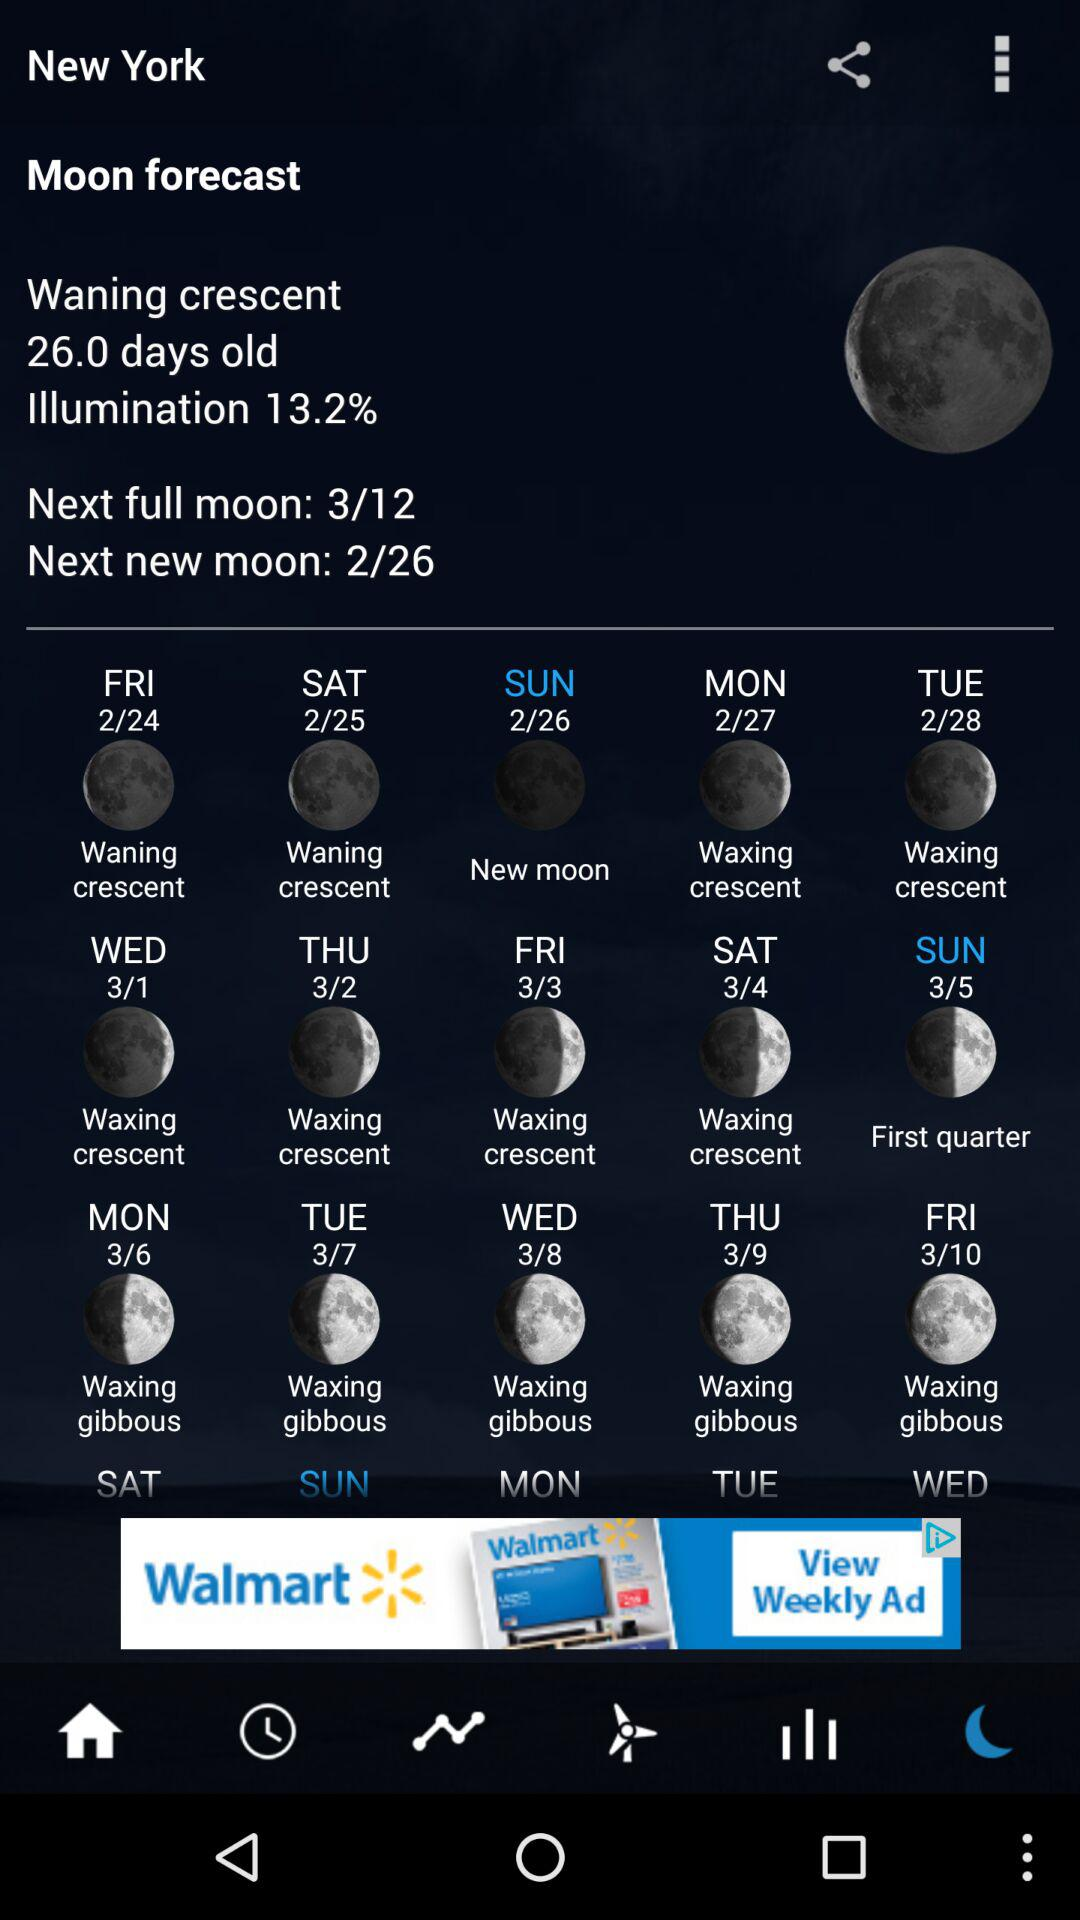What is the day on the selected date?
When the provided information is insufficient, respond with <no answer>. <no answer> 